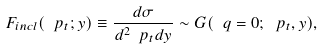Convert formula to latex. <formula><loc_0><loc_0><loc_500><loc_500>F _ { i n c l } ( \ p _ { t } ; y ) \equiv \frac { d \sigma } { d ^ { 2 } \ p _ { t } d y } \sim G ( \ q = 0 ; \ p _ { t } , y ) ,</formula> 